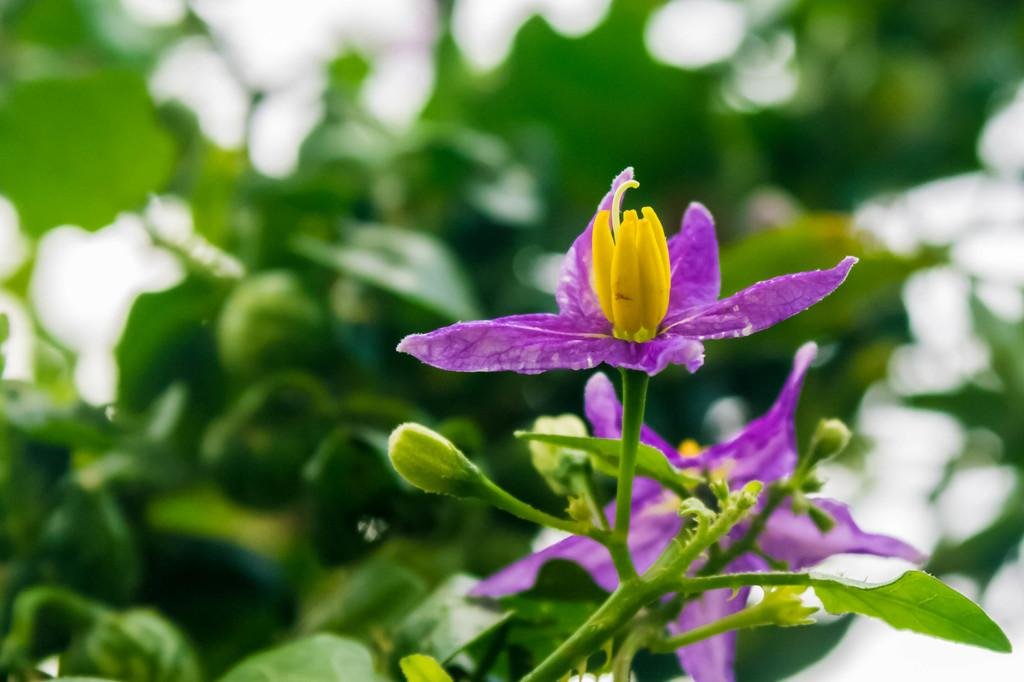What type of vegetation is present on the right side of the image? There are flowers in purple color on the right side of the image. What type of vegetation is present on the left side of the image? There are leaves on the left side of the image. What type of spade is used to plant the flowers in the image? There is no spade present in the image. What system is responsible for the growth of the flowers in the image? The image does not provide information about the growth system of the flowers. 